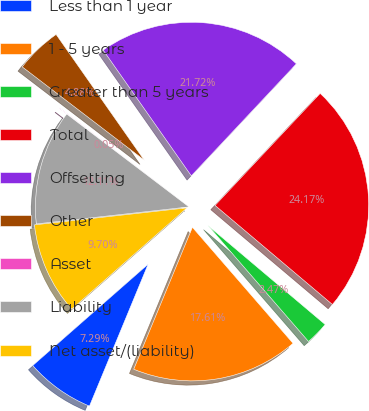Convert chart. <chart><loc_0><loc_0><loc_500><loc_500><pie_chart><fcel>Less than 1 year<fcel>1 - 5 years<fcel>Greater than 5 years<fcel>Total<fcel>Offsetting<fcel>Other<fcel>Asset<fcel>Liability<fcel>Net asset/(liability)<nl><fcel>7.29%<fcel>17.61%<fcel>2.47%<fcel>24.17%<fcel>21.72%<fcel>4.88%<fcel>0.05%<fcel>12.11%<fcel>9.7%<nl></chart> 